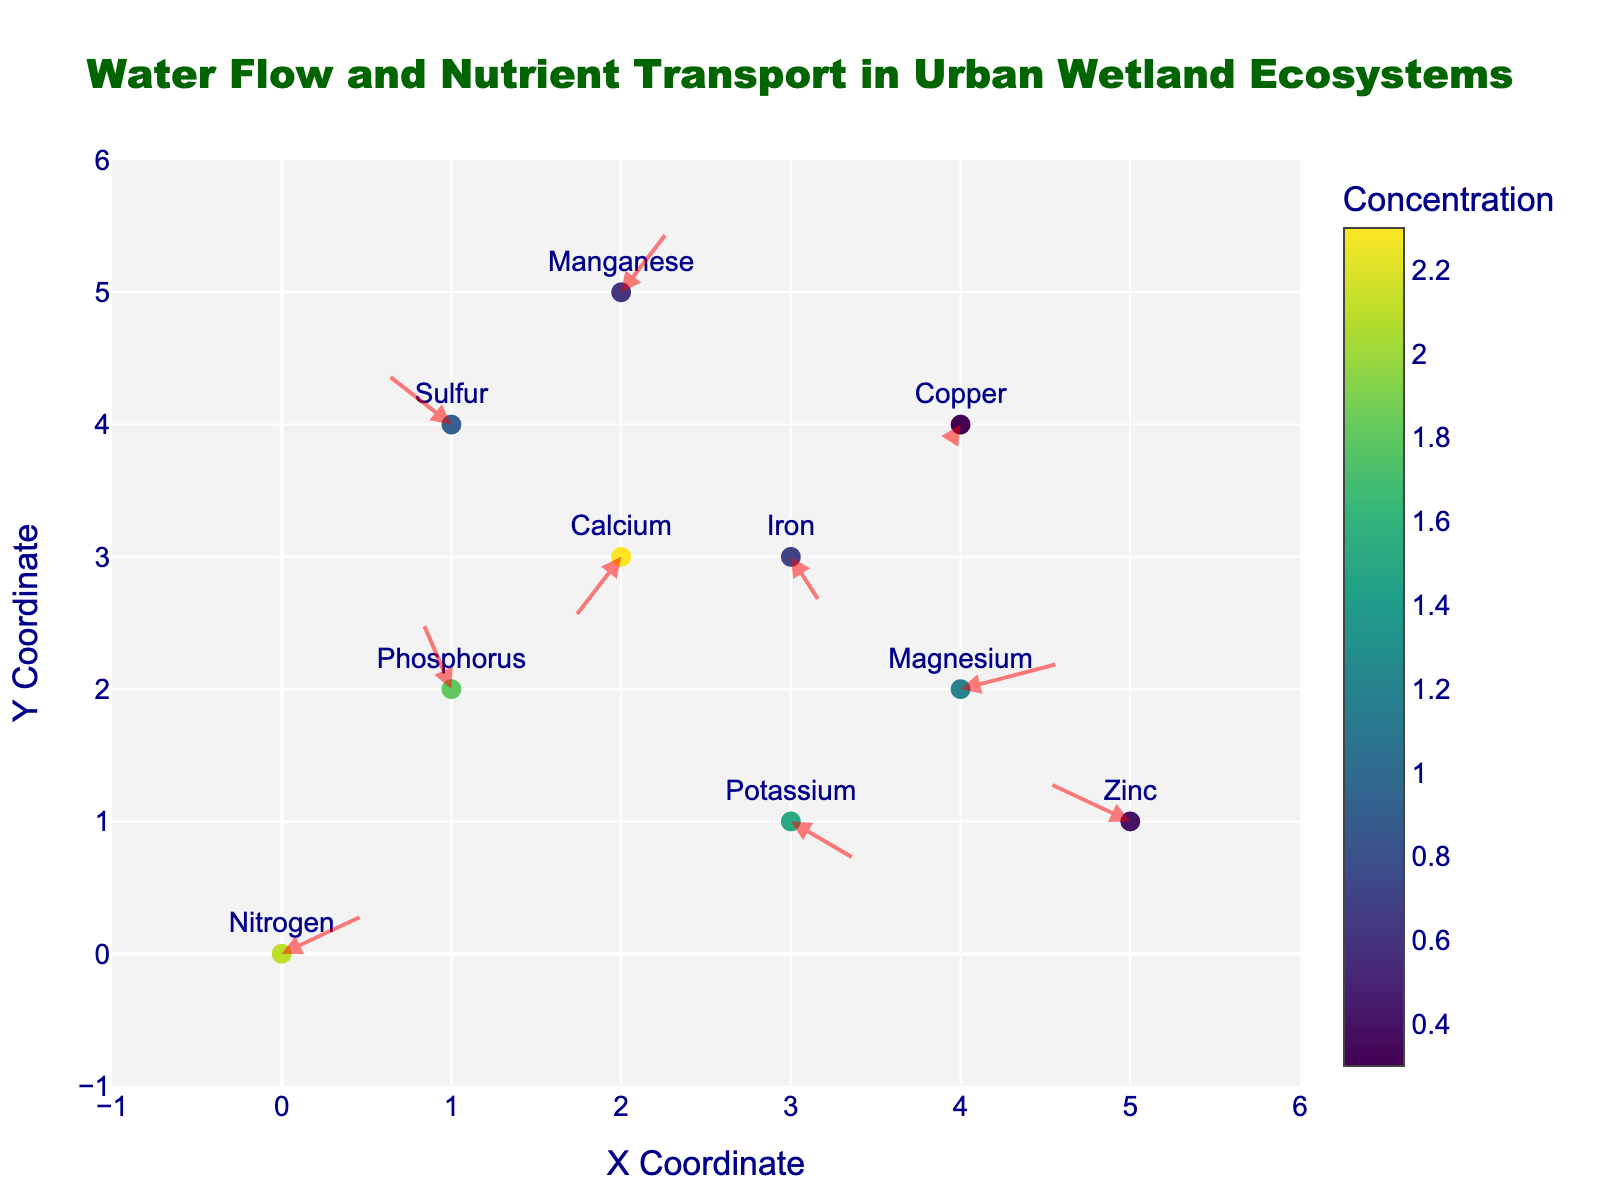What is the title of the plot? The title is located at the top center of the plot. It provides context on what the plot is about.
Answer: Water Flow and Nutrient Transport in Urban Wetland Ecosystems How many nutrients are represented in the plot? Count the distinct nutrient types labeled near the markers in the plot.
Answer: 10 What is the color scale used for? The color scale on the right side of the plot indicates the concentration of each nutrient, ranging from low to high concentration.
Answer: Indicating nutrient concentration Which nutrient has the highest concentration? Identify the darkest marker on the plot, which corresponds to the highest value on the color scale.
Answer: Calcium At which coordinates is Calcium located? Locate the label for Calcium on the plot and note its X and Y coordinates.
Answer: (2,3) Compare the flow direction vectors for Nitrogen and Phosphorus. Which one has a more positive horizontal flow? Look at the horizontal component (U) of the vectors for Nitrogen and Phosphorus. Compare these values.
Answer: Nitrogen What is the average concentration of all nutrients in the plot? Sum up all the concentrations and divide by the number of nutrient points: (2.1 + 1.8 + 1.5 + 2.3 + 1.2 + 0.9 + 0.7 + 0.4 + 0.6 + 0.3) / 10.
Answer: 1.18 For which coordinates is the horizontal flow direction most negative? Identify the point with the most negative U value and note its coordinates.
Answer: (5,1) How many arrows point upwards (i.e., have a positive vertical component V)? Count the arrows that have a vertical component greater than zero.
Answer: 6 Which nutrient has the smallest concentration and what is its flow direction vector? Locate the nutrient with the lightest color on the plot corresponding to the lowest value on the color scale, and check its U and V components.
Answer: Copper, (-0.1, -0.2) 